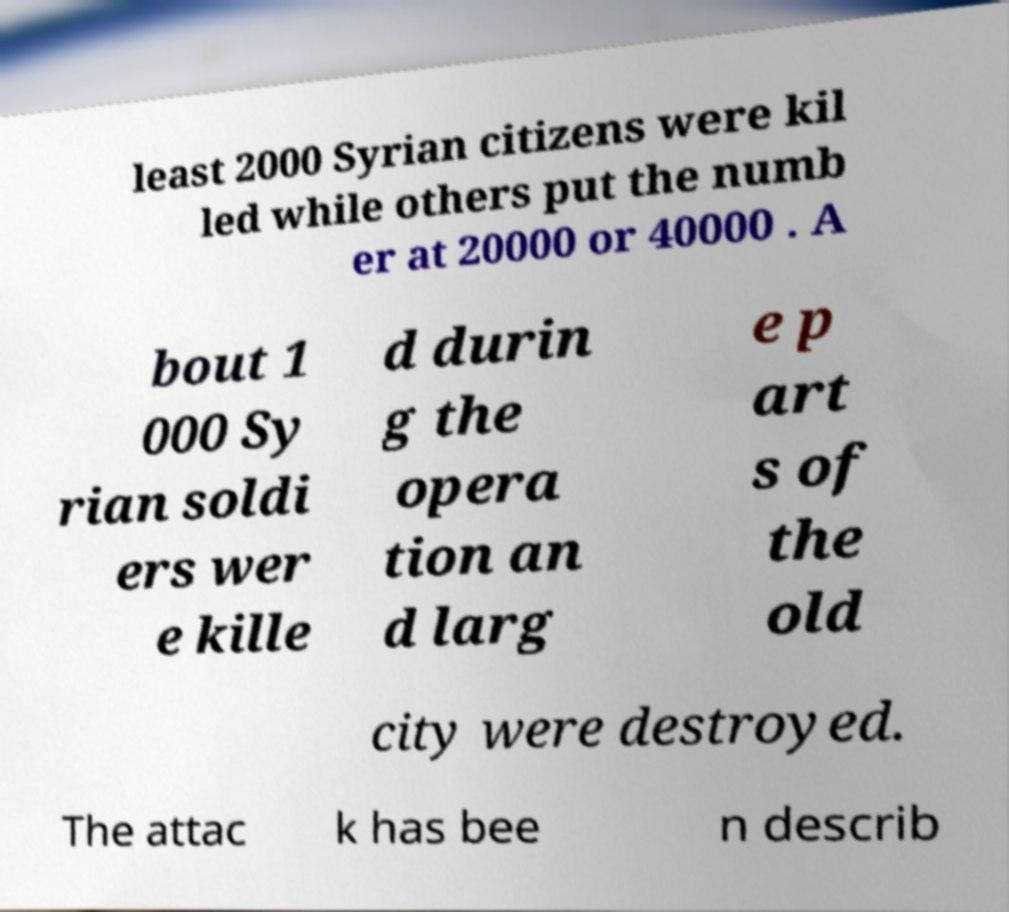Can you accurately transcribe the text from the provided image for me? least 2000 Syrian citizens were kil led while others put the numb er at 20000 or 40000 . A bout 1 000 Sy rian soldi ers wer e kille d durin g the opera tion an d larg e p art s of the old city were destroyed. The attac k has bee n describ 